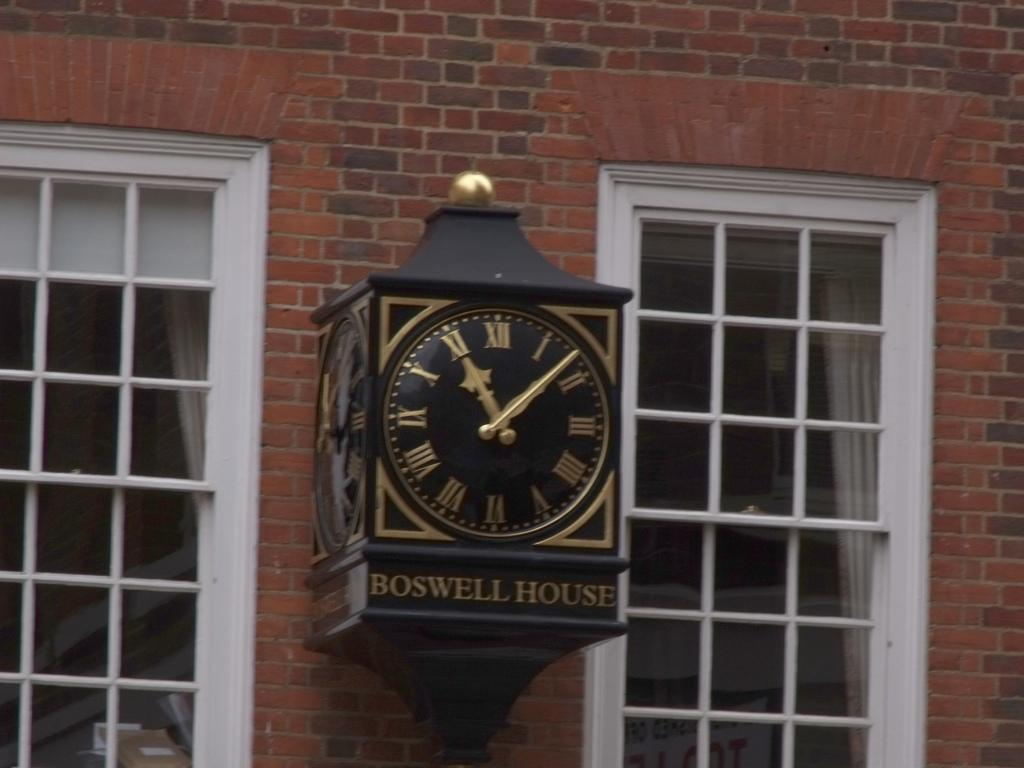<image>
Provide a brief description of the given image. A clock is shown on a red brick building that says Boswell House. 